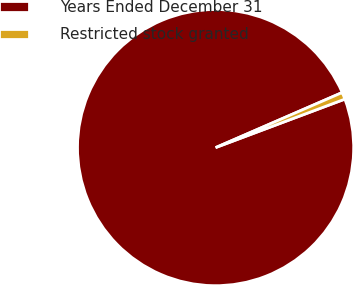<chart> <loc_0><loc_0><loc_500><loc_500><pie_chart><fcel>Years Ended December 31<fcel>Restricted stock granted<nl><fcel>99.18%<fcel>0.82%<nl></chart> 